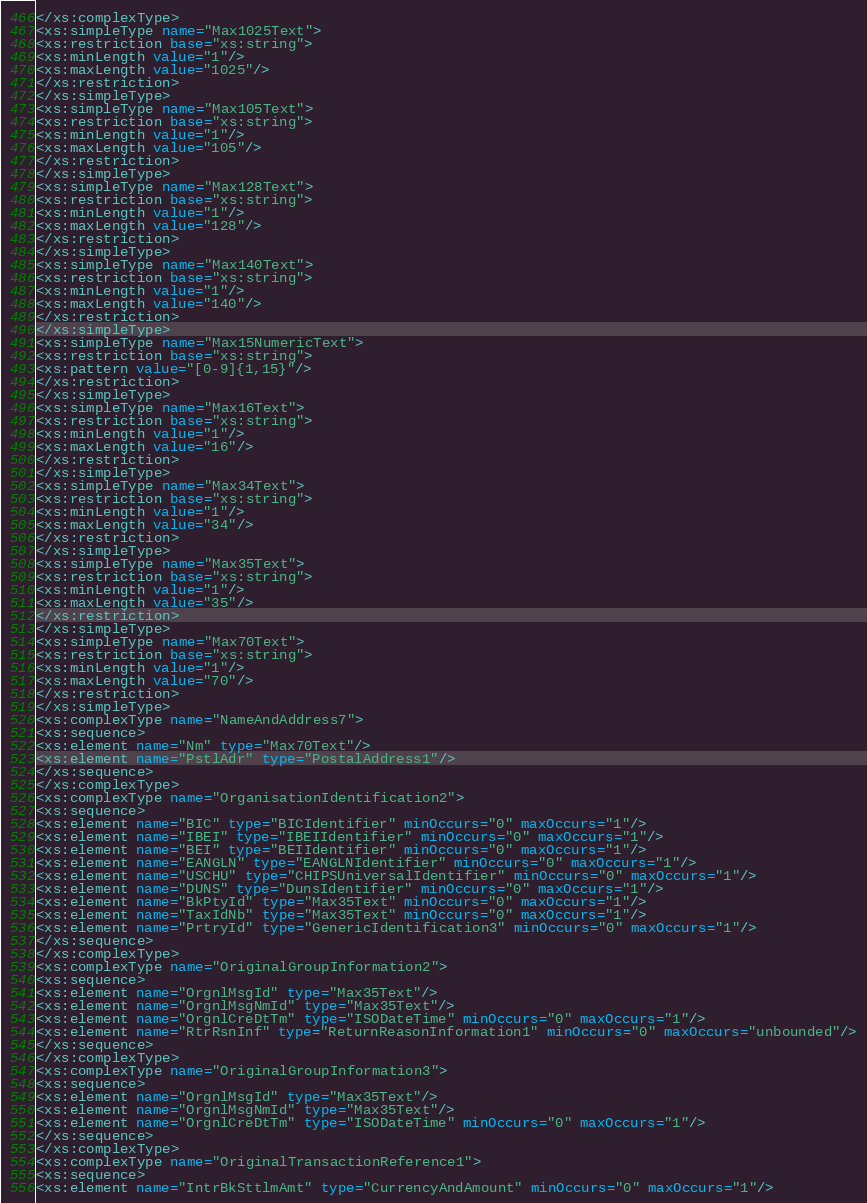<code> <loc_0><loc_0><loc_500><loc_500><_XML_></xs:complexType>
<xs:simpleType name="Max1025Text">
<xs:restriction base="xs:string">
<xs:minLength value="1"/>
<xs:maxLength value="1025"/>
</xs:restriction>
</xs:simpleType>
<xs:simpleType name="Max105Text">
<xs:restriction base="xs:string">
<xs:minLength value="1"/>
<xs:maxLength value="105"/>
</xs:restriction>
</xs:simpleType>
<xs:simpleType name="Max128Text">
<xs:restriction base="xs:string">
<xs:minLength value="1"/>
<xs:maxLength value="128"/>
</xs:restriction>
</xs:simpleType>
<xs:simpleType name="Max140Text">
<xs:restriction base="xs:string">
<xs:minLength value="1"/>
<xs:maxLength value="140"/>
</xs:restriction>
</xs:simpleType>
<xs:simpleType name="Max15NumericText">
<xs:restriction base="xs:string">
<xs:pattern value="[0-9]{1,15}"/>
</xs:restriction>
</xs:simpleType>
<xs:simpleType name="Max16Text">
<xs:restriction base="xs:string">
<xs:minLength value="1"/>
<xs:maxLength value="16"/>
</xs:restriction>
</xs:simpleType>
<xs:simpleType name="Max34Text">
<xs:restriction base="xs:string">
<xs:minLength value="1"/>
<xs:maxLength value="34"/>
</xs:restriction>
</xs:simpleType>
<xs:simpleType name="Max35Text">
<xs:restriction base="xs:string">
<xs:minLength value="1"/>
<xs:maxLength value="35"/>
</xs:restriction>
</xs:simpleType>
<xs:simpleType name="Max70Text">
<xs:restriction base="xs:string">
<xs:minLength value="1"/>
<xs:maxLength value="70"/>
</xs:restriction>
</xs:simpleType>
<xs:complexType name="NameAndAddress7">
<xs:sequence>
<xs:element name="Nm" type="Max70Text"/>
<xs:element name="PstlAdr" type="PostalAddress1"/>
</xs:sequence>
</xs:complexType>
<xs:complexType name="OrganisationIdentification2">
<xs:sequence>
<xs:element name="BIC" type="BICIdentifier" minOccurs="0" maxOccurs="1"/>
<xs:element name="IBEI" type="IBEIIdentifier" minOccurs="0" maxOccurs="1"/>
<xs:element name="BEI" type="BEIIdentifier" minOccurs="0" maxOccurs="1"/>
<xs:element name="EANGLN" type="EANGLNIdentifier" minOccurs="0" maxOccurs="1"/>
<xs:element name="USCHU" type="CHIPSUniversalIdentifier" minOccurs="0" maxOccurs="1"/>
<xs:element name="DUNS" type="DunsIdentifier" minOccurs="0" maxOccurs="1"/>
<xs:element name="BkPtyId" type="Max35Text" minOccurs="0" maxOccurs="1"/>
<xs:element name="TaxIdNb" type="Max35Text" minOccurs="0" maxOccurs="1"/>
<xs:element name="PrtryId" type="GenericIdentification3" minOccurs="0" maxOccurs="1"/>
</xs:sequence>
</xs:complexType>
<xs:complexType name="OriginalGroupInformation2">
<xs:sequence>
<xs:element name="OrgnlMsgId" type="Max35Text"/>
<xs:element name="OrgnlMsgNmId" type="Max35Text"/>
<xs:element name="OrgnlCreDtTm" type="ISODateTime" minOccurs="0" maxOccurs="1"/>
<xs:element name="RtrRsnInf" type="ReturnReasonInformation1" minOccurs="0" maxOccurs="unbounded"/>
</xs:sequence>
</xs:complexType>
<xs:complexType name="OriginalGroupInformation3">
<xs:sequence>
<xs:element name="OrgnlMsgId" type="Max35Text"/>
<xs:element name="OrgnlMsgNmId" type="Max35Text"/>
<xs:element name="OrgnlCreDtTm" type="ISODateTime" minOccurs="0" maxOccurs="1"/>
</xs:sequence>
</xs:complexType>
<xs:complexType name="OriginalTransactionReference1">
<xs:sequence>
<xs:element name="IntrBkSttlmAmt" type="CurrencyAndAmount" minOccurs="0" maxOccurs="1"/></code> 